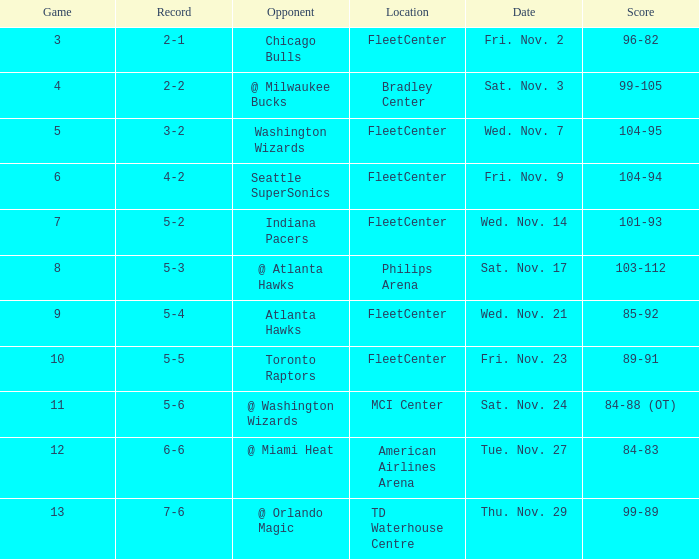How many games have a score of 85-92? 1.0. Help me parse the entirety of this table. {'header': ['Game', 'Record', 'Opponent', 'Location', 'Date', 'Score'], 'rows': [['3', '2-1', 'Chicago Bulls', 'FleetCenter', 'Fri. Nov. 2', '96-82'], ['4', '2-2', '@ Milwaukee Bucks', 'Bradley Center', 'Sat. Nov. 3', '99-105'], ['5', '3-2', 'Washington Wizards', 'FleetCenter', 'Wed. Nov. 7', '104-95'], ['6', '4-2', 'Seattle SuperSonics', 'FleetCenter', 'Fri. Nov. 9', '104-94'], ['7', '5-2', 'Indiana Pacers', 'FleetCenter', 'Wed. Nov. 14', '101-93'], ['8', '5-3', '@ Atlanta Hawks', 'Philips Arena', 'Sat. Nov. 17', '103-112'], ['9', '5-4', 'Atlanta Hawks', 'FleetCenter', 'Wed. Nov. 21', '85-92'], ['10', '5-5', 'Toronto Raptors', 'FleetCenter', 'Fri. Nov. 23', '89-91'], ['11', '5-6', '@ Washington Wizards', 'MCI Center', 'Sat. Nov. 24', '84-88 (OT)'], ['12', '6-6', '@ Miami Heat', 'American Airlines Arena', 'Tue. Nov. 27', '84-83'], ['13', '7-6', '@ Orlando Magic', 'TD Waterhouse Centre', 'Thu. Nov. 29', '99-89']]} 